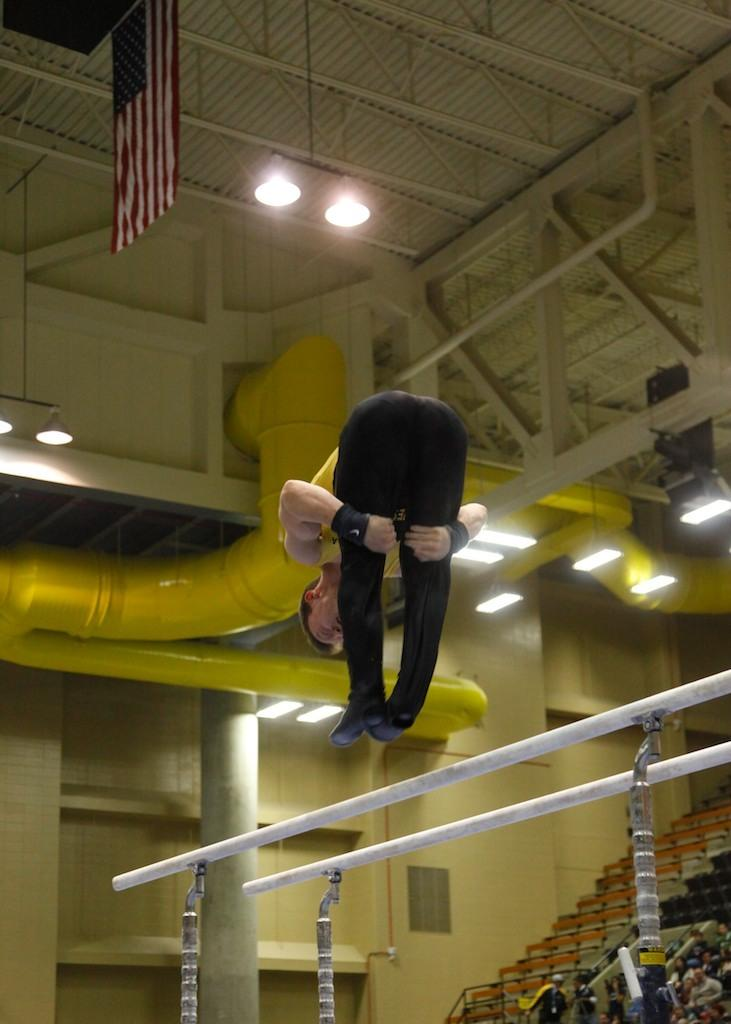What is the person in the image doing? There is a person in the air in the image, which suggests they might be flying or performing an aerial activity. What structures can be seen in the image? There are poles, a roof, a wall, and a pillar in the image. What additional objects are present in the image? There are people, a flag, lights, pipes, and other unspecified objects in the image. What type of grass can be seen growing on the hill in the image? There is no hill or grass present in the image; it features a person in the air and various structures and objects. 